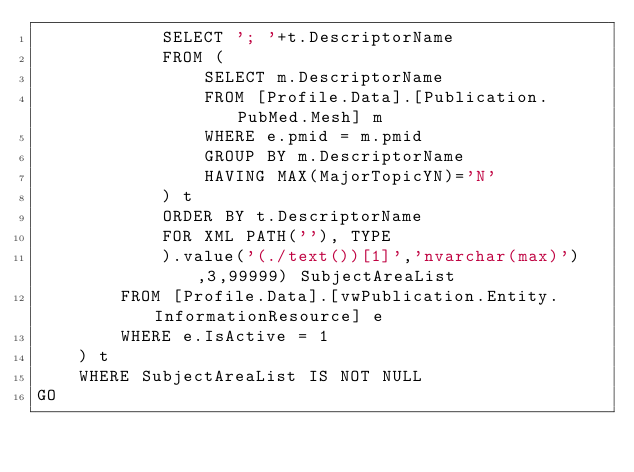Convert code to text. <code><loc_0><loc_0><loc_500><loc_500><_SQL_>			SELECT '; '+t.DescriptorName
			FROM (
				SELECT m.DescriptorName
				FROM [Profile.Data].[Publication.PubMed.Mesh] m
				WHERE e.pmid = m.pmid
				GROUP BY m.DescriptorName
				HAVING MAX(MajorTopicYN)='N'
			) t
			ORDER BY t.DescriptorName
			FOR XML PATH(''), TYPE
			).value('(./text())[1]','nvarchar(max)'),3,99999) SubjectAreaList
		FROM [Profile.Data].[vwPublication.Entity.InformationResource] e
		WHERE e.IsActive = 1
	) t
	WHERE SubjectAreaList IS NOT NULL
GO
</code> 